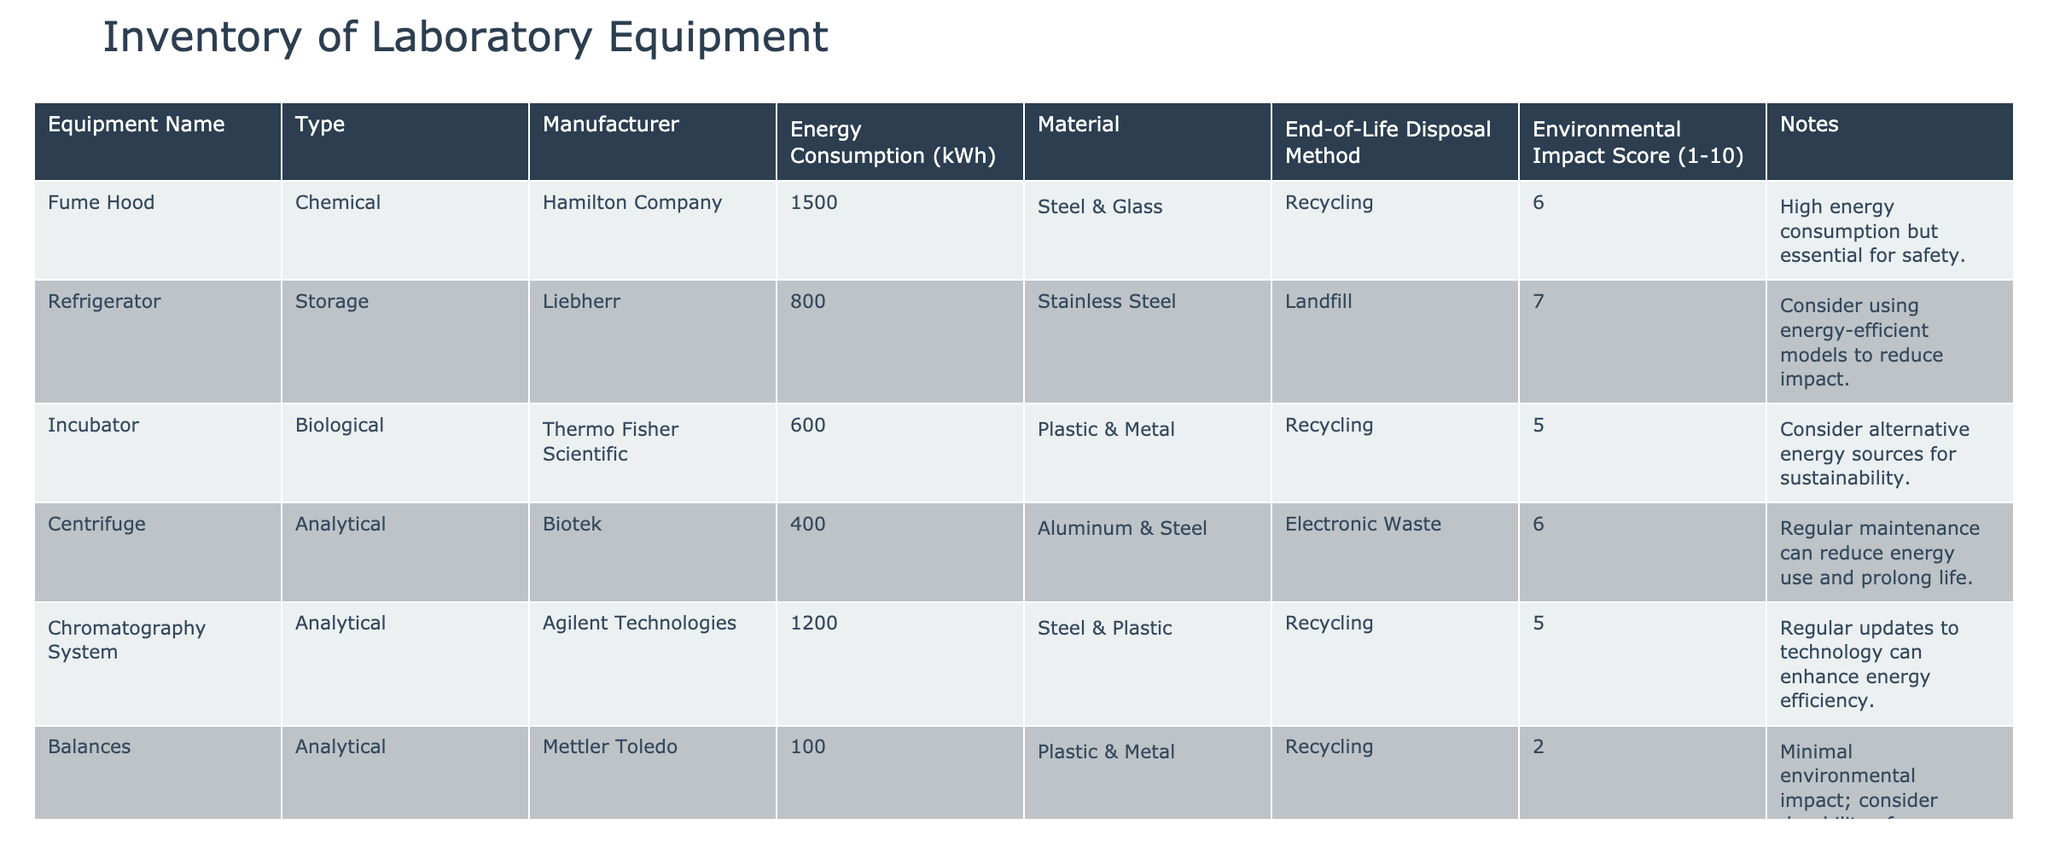What is the energy consumption of the Incubator? The table lists the energy consumption of each piece of equipment. For the Incubator, it states the value is 600 kWh.
Answer: 600 kWh How many pieces of equipment have an Environmental Impact Score of 6 or higher? By scanning the table, I can identify the scores for each piece of equipment: Fume Hood (6), Refrigerato (7), Centrifuge (6), Vacuum Pump (6). This gives us a total of 4 pieces of equipment with scores of 6 or higher.
Answer: 4 What is the total energy consumption of all the lab equipment listed? I will sum up the energy consumption values from each piece of equipment: 1500 + 800 + 600 + 400 + 1200 + 100 + 50 + 400 = 4050 kWh.
Answer: 4050 kWh Is the Disposal Method for Glassware Recycling? Checking the Disposal Method column for Glassware, it shows "Recycling". Hence, the statement is true.
Answer: Yes Which equipment has the lowest Environmental Impact Score, and what is that score? Observing the Environmental Impact Score column, the lowest score is 1 given to Glassware. Thus, Glassware is the equipment with the lowest score.
Answer: Glassware, Score: 1 What is the average Environmental Impact Score of the equipment with energy consumption over 700 kWh? First, I filter the equipment with energy consumption over 700 kWh: Fume Hood (6), Refrigerator (7), and Chromatography System (5). The scores are (6 + 7 + 5) = 18, and the average is 18/3 = 6.
Answer: 6 Does the Incubator have a higher Environmental Impact Score than the Balances? When comparing the scores, the Incubator has a score of 5 and the Balances have a score of 2. Thus, the Incubator's score is higher.
Answer: Yes What disposal methods are listed for the Centrifuge and the Vacuum Pump? Checking the Disposal Method column for both Centrifuge and Vacuum Pump reveals the Centrifuge uses Electronic Waste and the Vacuum Pump uses Electronic Waste as well.
Answer: Both use Electronic Waste 